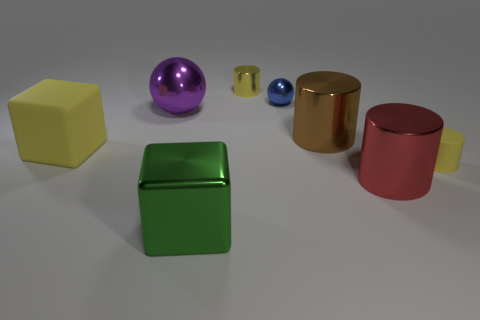What is the material of the big block that is right of the rubber thing behind the small cylinder that is in front of the blue metallic ball?
Make the answer very short. Metal. Are there any small objects of the same shape as the large purple object?
Ensure brevity in your answer.  Yes. What shape is the red thing that is the same size as the purple shiny object?
Your response must be concise. Cylinder. How many shiny cylinders are both behind the brown thing and to the right of the brown cylinder?
Make the answer very short. 0. Are there fewer small yellow metal cylinders in front of the big yellow rubber cube than large cyan metallic blocks?
Offer a very short reply. No. Is there a yellow matte thing of the same size as the green object?
Offer a terse response. Yes. What color is the small cylinder that is made of the same material as the green object?
Ensure brevity in your answer.  Yellow. What number of big green shiny cubes are behind the rubber object left of the red metal cylinder?
Give a very brief answer. 0. There is a yellow thing that is on the right side of the big purple shiny thing and to the left of the blue thing; what material is it made of?
Your response must be concise. Metal. There is a small thing in front of the big yellow thing; does it have the same shape as the blue thing?
Offer a very short reply. No. 